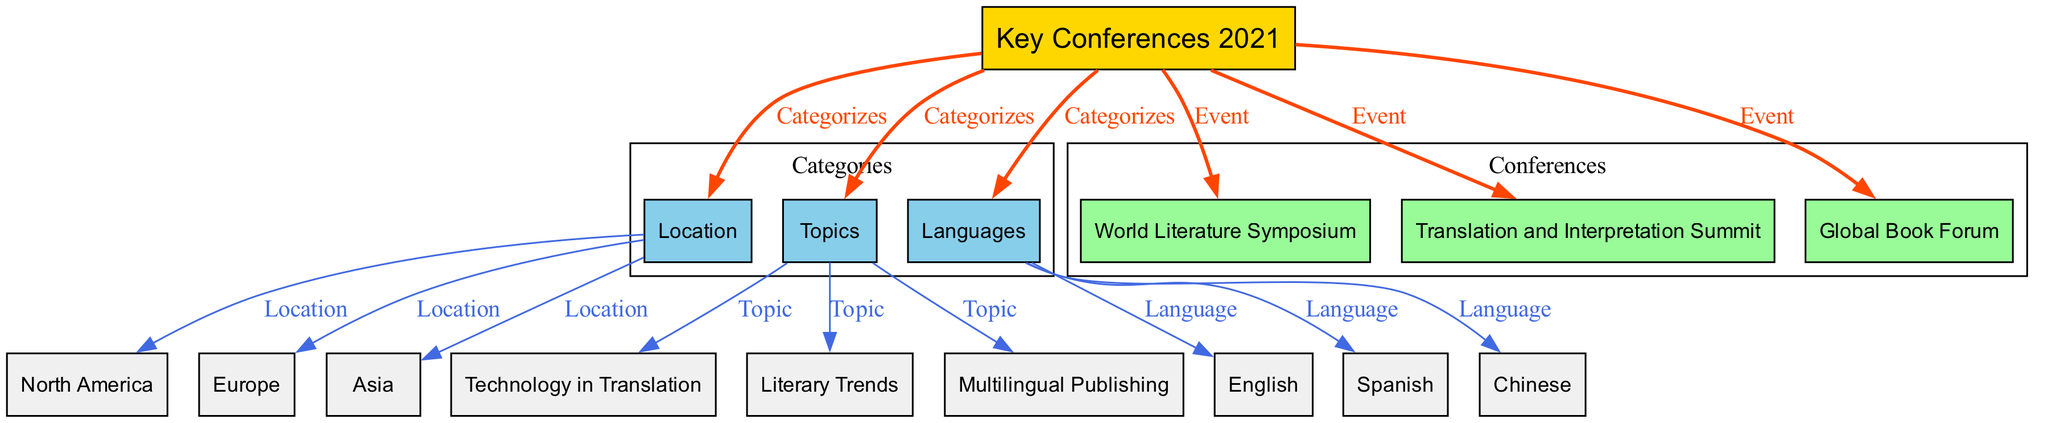What are the three key conferences in 2021? The diagram indicates that there are three conferences listed under the node "Key Conferences 2021": World Literature Symposium, Translation and Interpretation Summit, and Global Book Forum.
Answer: World Literature Symposium, Translation and Interpretation Summit, Global Book Forum How many locations are categorized in the diagram? The diagram categorizes the conferences by location, showing three distinct locations: North America, Europe, and Asia.
Answer: 3 What is the primary language of presentations at the Translation and Interpretation Summit? The diagram connects the Translation and Interpretation Summit to the node for languages, and it shows that English, Spanish, and Chinese are the languages categorized for the conferences. However, since all conferences are not specifically tied to a primary language, we observe the general connections from the topic.
Answer: English, Spanish, Chinese Which topic is covered in the key conferences related to technology? The diagram shows a clear relationship indicating that the topic "Technology in Translation" is directly connected to the category of topics covered at the conferences. This infers that this topic is a part of the key conferences.
Answer: Technology in Translation How many edges connect the "Key Conferences 2021" node to other nodes? Upon reviewing the node "Key Conferences 2021," it can be seen that there are six edges leading out from this node to other nodes, categorizing the information into locations, topics, languages, and events.
Answer: 6 Which location corresponds to the Global Book Forum? By examining the edges from the node "Global Book Forum," it’s clear that this conference is associated specifically with the location "North America."
Answer: North America Can you name one topic covered at the conferences related to multilingual publishing? The diagram establishes a direct link showing that "Multilingual Publishing" is indeed one of the topics covered in the key conferences, thus it is specifically identified in the topics category.
Answer: Multilingual Publishing Which conference focuses on literary trends? The diagram categorizes "Literary Trends" as a topic, and it specifies that this topic is related to the events that fall under the "Key Conferences 2021", hence identifying it clearly among the listed events.
Answer: World Literature Symposium, Translation and Interpretation Summit, Global Book Forum What color represents the nodes that categorize the type of conferences? The diagram visually distinguishes the nodes for categories such as Location, Topics, and Languages by using the color light blue (#87CEEB) in the diagram. This is consistent across all category nodes indicated.
Answer: Light blue 